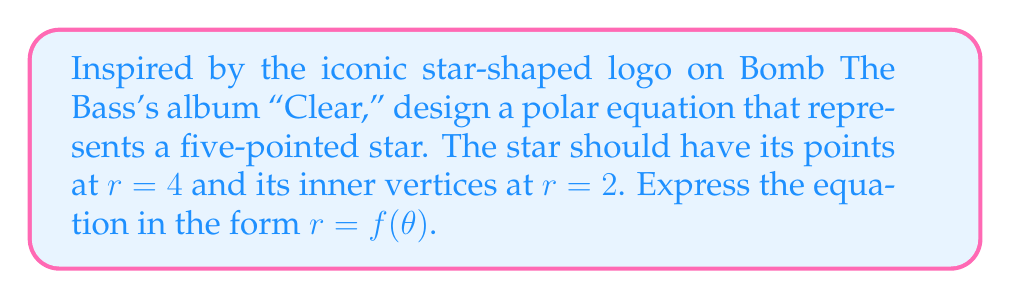Provide a solution to this math problem. To create a polar equation for a five-pointed star, we can use a sinusoidal function with the following steps:

1) The basic form of the equation will be:
   $$r = a + b \sin(c\theta)$$
   where $a$ is the average radius, $b$ is the amplitude of the variation, and $c$ determines the number of points.

2) For a five-pointed star, we need 5 maxima and 5 minima in a full $2\pi$ rotation. This means $c = \frac{5}{2}$.

3) The maximum radius (at the points) is 4, and the minimum radius (at the inner vertices) is 2. So:
   $a + b = 4$ (max)
   $a - b = 2$ (min)

4) Solving these equations:
   $a = \frac{4 + 2}{2} = 3$
   $b = \frac{4 - 2}{2} = 1$

5) Therefore, our equation becomes:
   $$r = 3 + \sin(\frac{5}{2}\theta)$$

6) However, we want the sine term to be positive at the star's points. The sine function is positive when $\frac{5}{2}\theta$ is between 0 and $\pi$. To shift this by $\frac{\pi}{2}$, we can subtract $\frac{\pi}{2}$ from the argument of sine:

   $$r = 3 + \sin(\frac{5}{2}\theta - \frac{\pi}{2})$$

7) This can be simplified using the cosine function:
   $$r = 3 + \cos(\frac{5}{2}\theta)$$

This equation will produce a five-pointed star with the desired dimensions, reminiscent of the star on the "Clear" album cover.
Answer: $$r = 3 + \cos(\frac{5}{2}\theta)$$ 